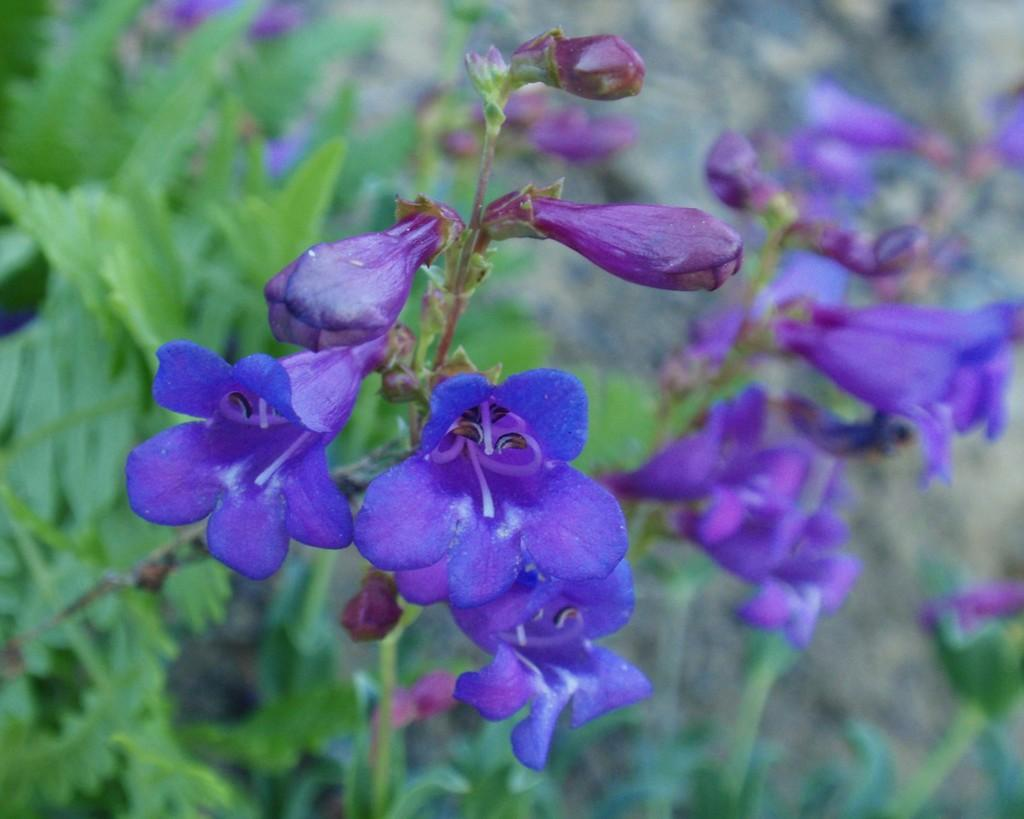What type of plants can be seen in the image? There are flowering plants in the image. Can you describe the setting where the plants are located? The image may have been taken in a garden. How many horses are visible in the image? There are no horses present in the image; it features flowering plants in a possible garden setting. 